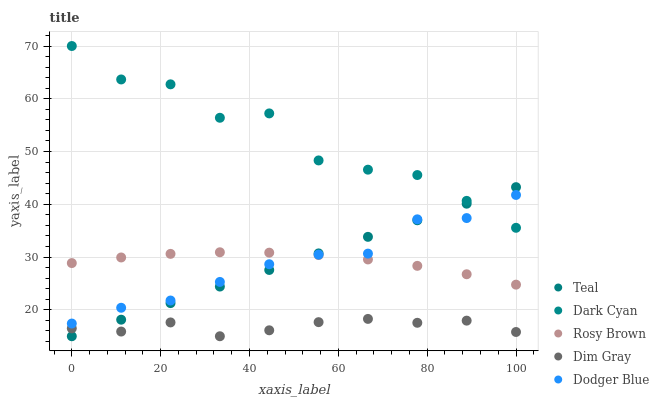Does Dim Gray have the minimum area under the curve?
Answer yes or no. Yes. Does Dark Cyan have the maximum area under the curve?
Answer yes or no. Yes. Does Rosy Brown have the minimum area under the curve?
Answer yes or no. No. Does Rosy Brown have the maximum area under the curve?
Answer yes or no. No. Is Teal the smoothest?
Answer yes or no. Yes. Is Dark Cyan the roughest?
Answer yes or no. Yes. Is Dim Gray the smoothest?
Answer yes or no. No. Is Dim Gray the roughest?
Answer yes or no. No. Does Dim Gray have the lowest value?
Answer yes or no. Yes. Does Rosy Brown have the lowest value?
Answer yes or no. No. Does Dark Cyan have the highest value?
Answer yes or no. Yes. Does Rosy Brown have the highest value?
Answer yes or no. No. Is Dim Gray less than Rosy Brown?
Answer yes or no. Yes. Is Dodger Blue greater than Dim Gray?
Answer yes or no. Yes. Does Teal intersect Rosy Brown?
Answer yes or no. Yes. Is Teal less than Rosy Brown?
Answer yes or no. No. Is Teal greater than Rosy Brown?
Answer yes or no. No. Does Dim Gray intersect Rosy Brown?
Answer yes or no. No. 